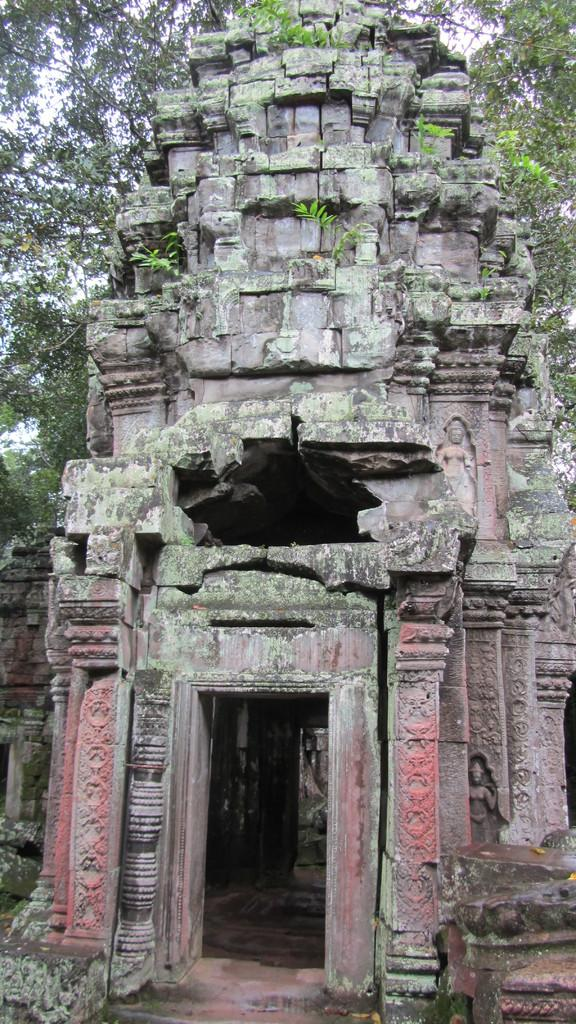What is the main subject of the image? There is an old monument in the image. Are there any decorations or features on the monument? Yes, there are plants on the monument. What can be seen in the background of the image? There are trees visible in the background of the image. How many items are on the list that is hanging from the monument? There is no list present in the image; it only features an old monument with plants on it and trees in the background. 